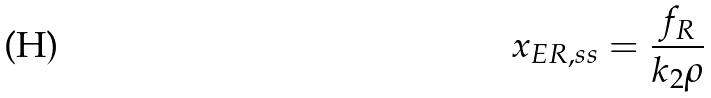<formula> <loc_0><loc_0><loc_500><loc_500>x _ { E R , s s } = \frac { f _ { R } } { k _ { 2 } \rho }</formula> 